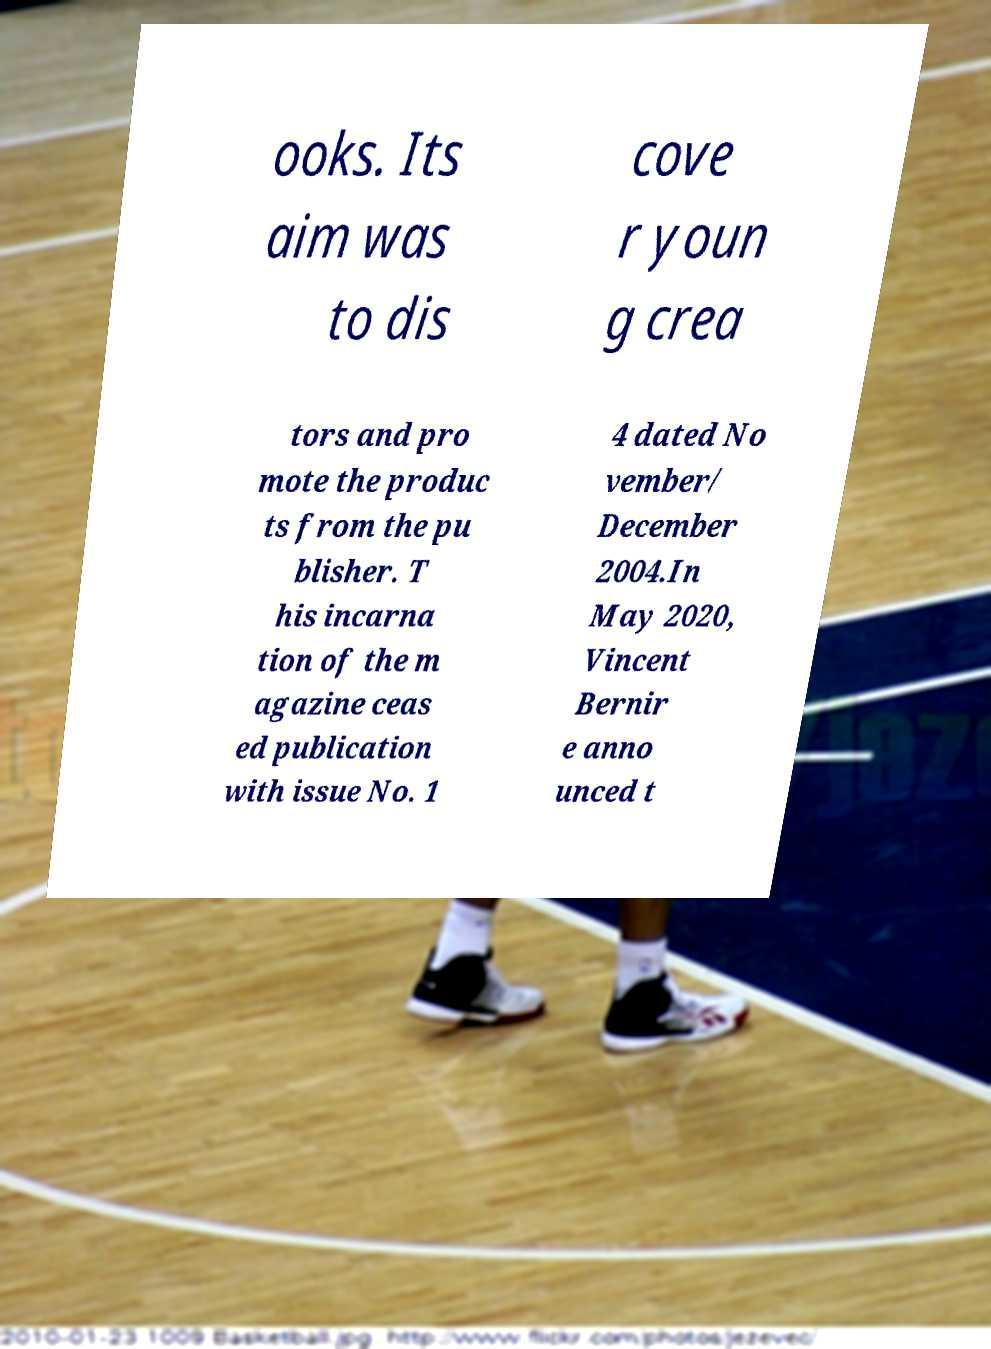For documentation purposes, I need the text within this image transcribed. Could you provide that? ooks. Its aim was to dis cove r youn g crea tors and pro mote the produc ts from the pu blisher. T his incarna tion of the m agazine ceas ed publication with issue No. 1 4 dated No vember/ December 2004.In May 2020, Vincent Bernir e anno unced t 